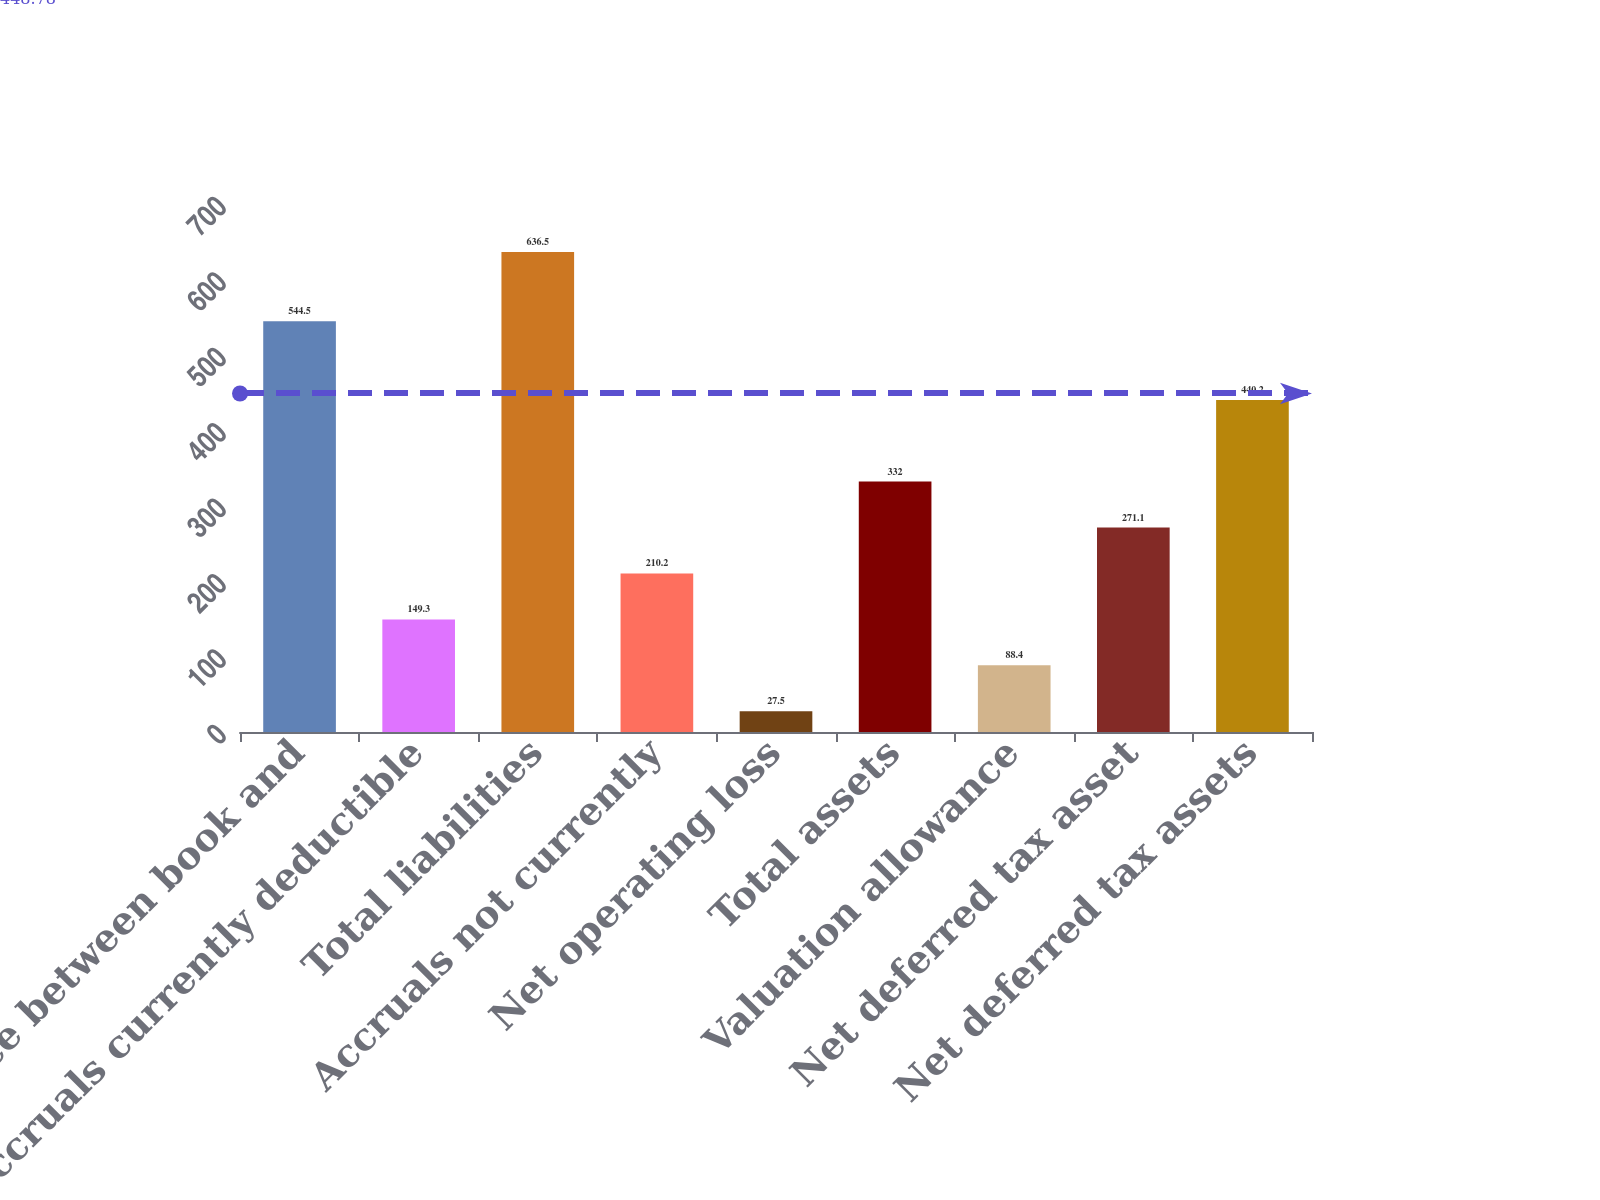Convert chart. <chart><loc_0><loc_0><loc_500><loc_500><bar_chart><fcel>Difference between book and<fcel>Accruals currently deductible<fcel>Total liabilities<fcel>Accruals not currently<fcel>Net operating loss<fcel>Total assets<fcel>Valuation allowance<fcel>Net deferred tax asset<fcel>Net deferred tax assets<nl><fcel>544.5<fcel>149.3<fcel>636.5<fcel>210.2<fcel>27.5<fcel>332<fcel>88.4<fcel>271.1<fcel>440.2<nl></chart> 